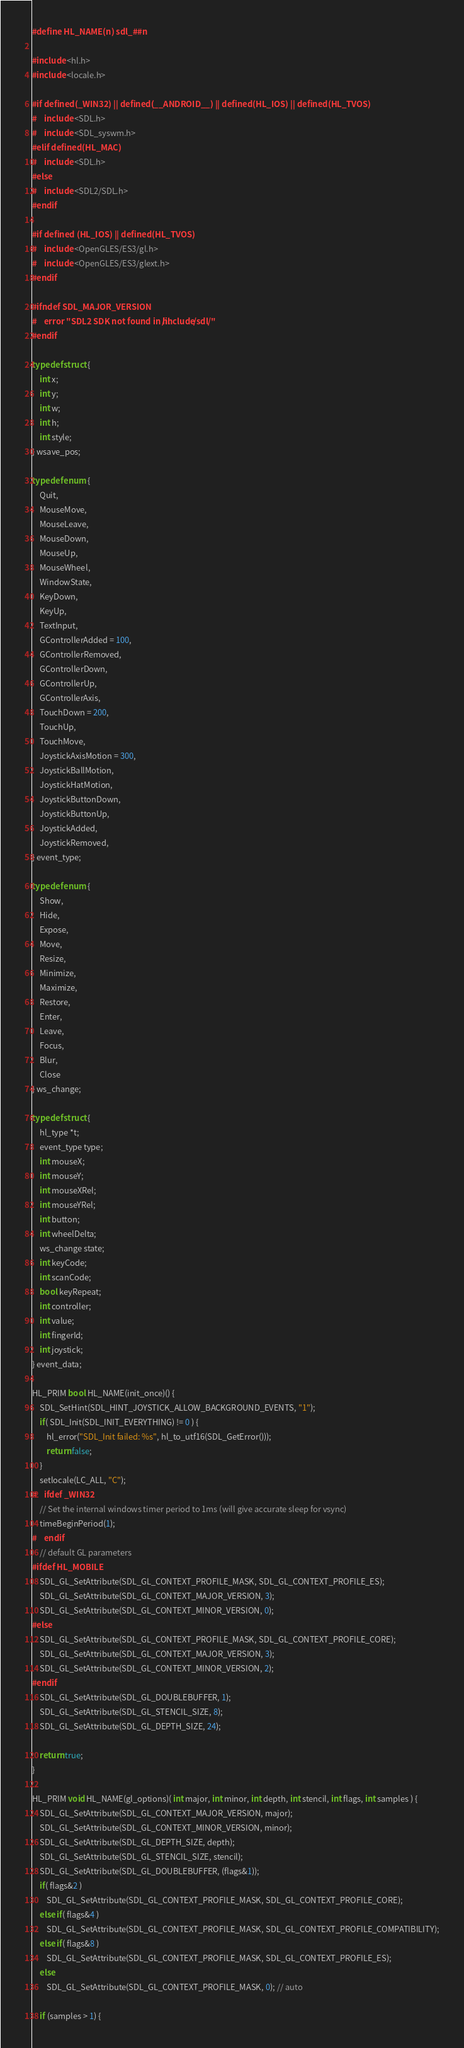Convert code to text. <code><loc_0><loc_0><loc_500><loc_500><_C_>#define HL_NAME(n) sdl_##n

#include <hl.h>
#include <locale.h>

#if defined(_WIN32) || defined(__ANDROID__) || defined(HL_IOS) || defined(HL_TVOS)
#	include <SDL.h>
#	include <SDL_syswm.h>
#elif defined(HL_MAC)
#	include <SDL.h>
#else
#	include <SDL2/SDL.h>
#endif

#if defined (HL_IOS) || defined(HL_TVOS)
#	include <OpenGLES/ES3/gl.h>
#	include <OpenGLES/ES3/glext.h>
#endif

#ifndef SDL_MAJOR_VERSION
#	error "SDL2 SDK not found in hl/include/sdl/"
#endif

typedef struct {
	int x;
	int y;
	int w;
	int h;
	int style;
} wsave_pos;

typedef enum {
	Quit,
	MouseMove,
	MouseLeave,
	MouseDown,
	MouseUp,
	MouseWheel,
	WindowState,
	KeyDown,
	KeyUp,
	TextInput,
	GControllerAdded = 100,
	GControllerRemoved,
	GControllerDown,
	GControllerUp,
	GControllerAxis,
	TouchDown = 200,
	TouchUp,
	TouchMove,
	JoystickAxisMotion = 300,
	JoystickBallMotion,
	JoystickHatMotion,
	JoystickButtonDown,
	JoystickButtonUp,
	JoystickAdded,
	JoystickRemoved,
} event_type;

typedef enum {
	Show,
	Hide,
	Expose,
	Move,
	Resize,
	Minimize,
	Maximize,
	Restore,
	Enter,
	Leave,
	Focus,
	Blur,
	Close
} ws_change;

typedef struct {
	hl_type *t;
	event_type type;
	int mouseX;
	int mouseY;
	int mouseXRel;
	int mouseYRel;
	int button;
	int wheelDelta;
	ws_change state;
	int keyCode;
	int scanCode;
	bool keyRepeat;
	int controller;
	int value;
	int fingerId;
	int joystick;
} event_data;

HL_PRIM bool HL_NAME(init_once)() {
	SDL_SetHint(SDL_HINT_JOYSTICK_ALLOW_BACKGROUND_EVENTS, "1");
	if( SDL_Init(SDL_INIT_EVERYTHING) != 0 ) {
		hl_error("SDL_Init failed: %s", hl_to_utf16(SDL_GetError()));
		return false;
	}
	setlocale(LC_ALL, "C");
#	ifdef _WIN32
	// Set the internal windows timer period to 1ms (will give accurate sleep for vsync)
	timeBeginPeriod(1);
#	endif
	// default GL parameters
#ifdef HL_MOBILE
	SDL_GL_SetAttribute(SDL_GL_CONTEXT_PROFILE_MASK, SDL_GL_CONTEXT_PROFILE_ES);
	SDL_GL_SetAttribute(SDL_GL_CONTEXT_MAJOR_VERSION, 3);
	SDL_GL_SetAttribute(SDL_GL_CONTEXT_MINOR_VERSION, 0);
#else
	SDL_GL_SetAttribute(SDL_GL_CONTEXT_PROFILE_MASK, SDL_GL_CONTEXT_PROFILE_CORE);
	SDL_GL_SetAttribute(SDL_GL_CONTEXT_MAJOR_VERSION, 3);
	SDL_GL_SetAttribute(SDL_GL_CONTEXT_MINOR_VERSION, 2);
#endif
	SDL_GL_SetAttribute(SDL_GL_DOUBLEBUFFER, 1);
	SDL_GL_SetAttribute(SDL_GL_STENCIL_SIZE, 8);
	SDL_GL_SetAttribute(SDL_GL_DEPTH_SIZE, 24);

	return true;
}

HL_PRIM void HL_NAME(gl_options)( int major, int minor, int depth, int stencil, int flags, int samples ) {
	SDL_GL_SetAttribute(SDL_GL_CONTEXT_MAJOR_VERSION, major);
	SDL_GL_SetAttribute(SDL_GL_CONTEXT_MINOR_VERSION, minor);
	SDL_GL_SetAttribute(SDL_GL_DEPTH_SIZE, depth);
	SDL_GL_SetAttribute(SDL_GL_STENCIL_SIZE, stencil);
	SDL_GL_SetAttribute(SDL_GL_DOUBLEBUFFER, (flags&1));
	if( flags&2 )
		SDL_GL_SetAttribute(SDL_GL_CONTEXT_PROFILE_MASK, SDL_GL_CONTEXT_PROFILE_CORE);
	else if( flags&4 )
		SDL_GL_SetAttribute(SDL_GL_CONTEXT_PROFILE_MASK, SDL_GL_CONTEXT_PROFILE_COMPATIBILITY);
	else if( flags&8 )
		SDL_GL_SetAttribute(SDL_GL_CONTEXT_PROFILE_MASK, SDL_GL_CONTEXT_PROFILE_ES);
	else
		SDL_GL_SetAttribute(SDL_GL_CONTEXT_PROFILE_MASK, 0); // auto

	if (samples > 1) {</code> 